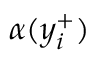<formula> <loc_0><loc_0><loc_500><loc_500>\alpha ( y _ { i } ^ { + } )</formula> 